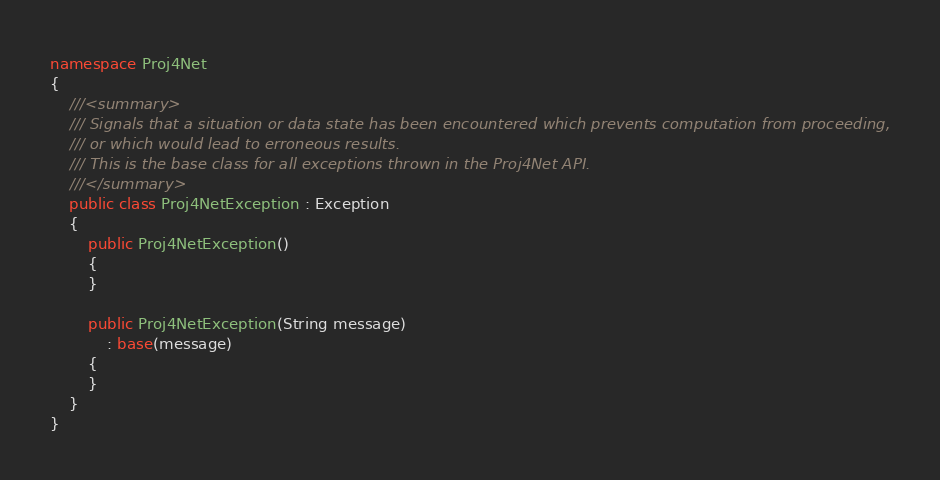<code> <loc_0><loc_0><loc_500><loc_500><_C#_>namespace Proj4Net
{
    ///<summary>
    /// Signals that a situation or data state has been encountered which prevents computation from proceeding,
    /// or which would lead to erroneous results.
    /// This is the base class for all exceptions thrown in the Proj4Net API.
    ///</summary>
    public class Proj4NetException : Exception
    {
        public Proj4NetException()
        {
        }

        public Proj4NetException(String message)
            : base(message)
        {
        }
    }
}</code> 